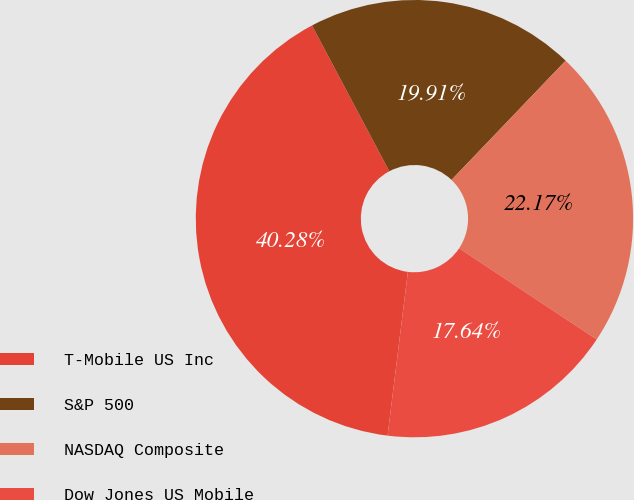Convert chart. <chart><loc_0><loc_0><loc_500><loc_500><pie_chart><fcel>T-Mobile US Inc<fcel>S&P 500<fcel>NASDAQ Composite<fcel>Dow Jones US Mobile<nl><fcel>40.28%<fcel>19.91%<fcel>22.17%<fcel>17.64%<nl></chart> 